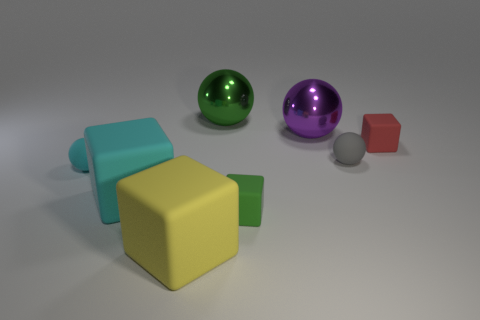How many green rubber things are the same size as the yellow cube?
Your answer should be very brief. 0. What size is the yellow block that is made of the same material as the cyan cube?
Give a very brief answer. Large. What number of things are tiny matte cubes behind the tiny cyan ball or large shiny spheres?
Your answer should be very brief. 3. Do the large cyan cube and the green object in front of the gray ball have the same material?
Your answer should be compact. Yes. Is there a cyan sphere that has the same material as the tiny cyan object?
Provide a succinct answer. No. What number of things are tiny rubber things that are to the left of the green shiny sphere or matte balls behind the small cyan ball?
Provide a succinct answer. 2. There is a purple thing; is its shape the same as the tiny red rubber thing in front of the large purple object?
Give a very brief answer. No. How many other objects are there of the same shape as the red object?
Keep it short and to the point. 3. How many things are blocks or matte balls?
Offer a terse response. 6. There is a large metallic object in front of the green object that is left of the tiny green object; what shape is it?
Offer a very short reply. Sphere. 